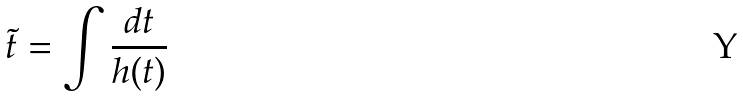Convert formula to latex. <formula><loc_0><loc_0><loc_500><loc_500>\tilde { t } = \int \frac { d t } { h ( t ) }</formula> 